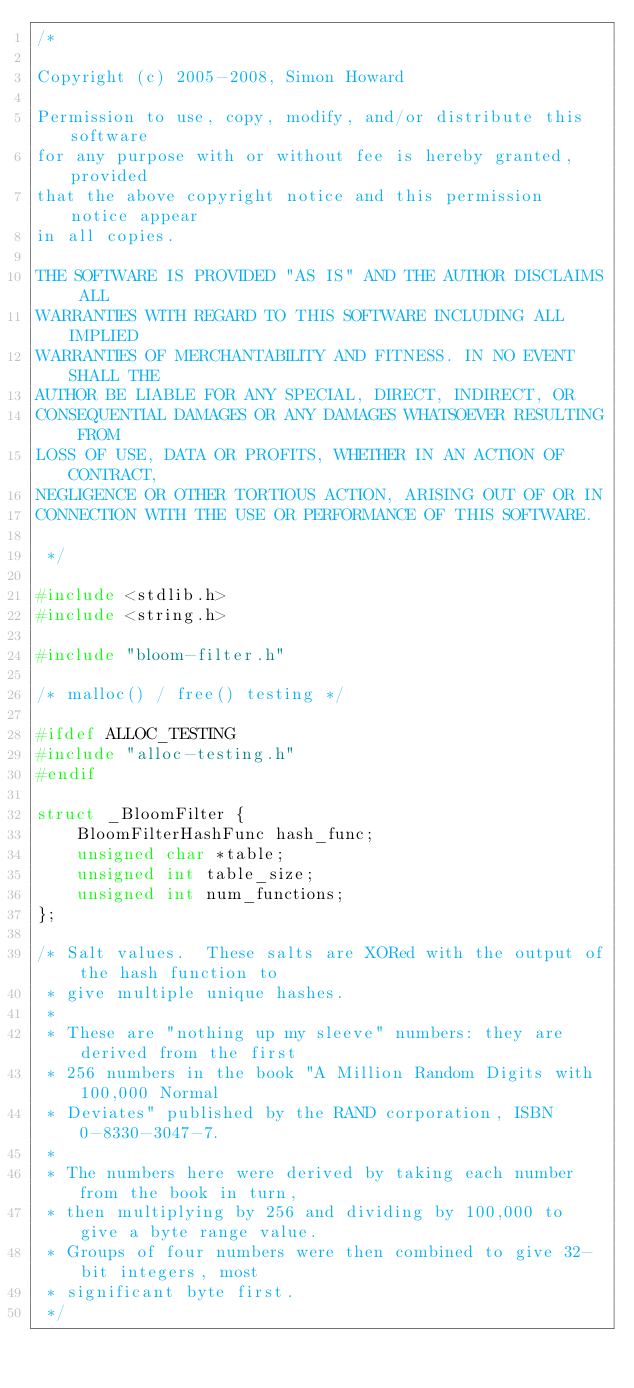<code> <loc_0><loc_0><loc_500><loc_500><_C_>/*

Copyright (c) 2005-2008, Simon Howard

Permission to use, copy, modify, and/or distribute this software 
for any purpose with or without fee is hereby granted, provided 
that the above copyright notice and this permission notice appear 
in all copies. 

THE SOFTWARE IS PROVIDED "AS IS" AND THE AUTHOR DISCLAIMS ALL 
WARRANTIES WITH REGARD TO THIS SOFTWARE INCLUDING ALL IMPLIED 
WARRANTIES OF MERCHANTABILITY AND FITNESS. IN NO EVENT SHALL THE 
AUTHOR BE LIABLE FOR ANY SPECIAL, DIRECT, INDIRECT, OR 
CONSEQUENTIAL DAMAGES OR ANY DAMAGES WHATSOEVER RESULTING FROM 
LOSS OF USE, DATA OR PROFITS, WHETHER IN AN ACTION OF CONTRACT, 
NEGLIGENCE OR OTHER TORTIOUS ACTION, ARISING OUT OF OR IN      
CONNECTION WITH THE USE OR PERFORMANCE OF THIS SOFTWARE. 

 */

#include <stdlib.h>
#include <string.h>

#include "bloom-filter.h"

/* malloc() / free() testing */

#ifdef ALLOC_TESTING
#include "alloc-testing.h"
#endif

struct _BloomFilter {
	BloomFilterHashFunc hash_func;
	unsigned char *table;
	unsigned int table_size;
	unsigned int num_functions;
};

/* Salt values.  These salts are XORed with the output of the hash function to
 * give multiple unique hashes.
 *
 * These are "nothing up my sleeve" numbers: they are derived from the first
 * 256 numbers in the book "A Million Random Digits with 100,000 Normal
 * Deviates" published by the RAND corporation, ISBN 0-8330-3047-7.
 *
 * The numbers here were derived by taking each number from the book in turn,
 * then multiplying by 256 and dividing by 100,000 to give a byte range value.
 * Groups of four numbers were then combined to give 32-bit integers, most
 * significant byte first.
 */
</code> 